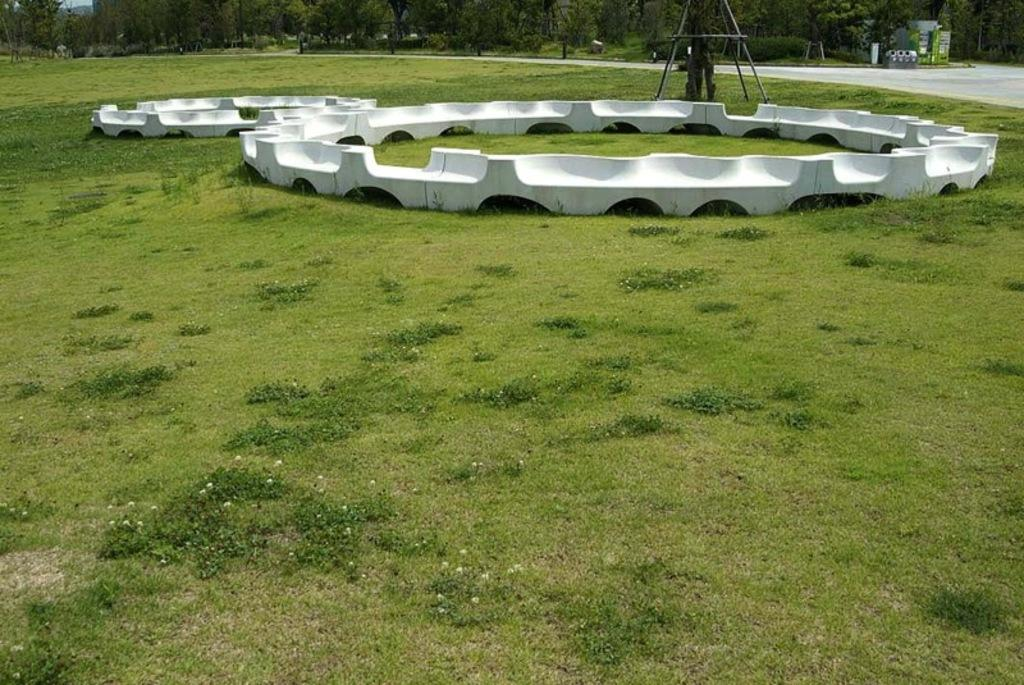What type of vegetation is present at the bottom of the image? There is grass and plants at the bottom of the image. What objects can be seen in the middle of the image? There are stones, a ladder, and a road in the middle of the image. What type of vegetation is present at the top of the image? There are trees at the top of the image. What color is the square glove in the image? There is no square glove present in the image. How does the digestion process of the plants in the image work? The image does not show the plants' digestion process; it only shows their appearance. 